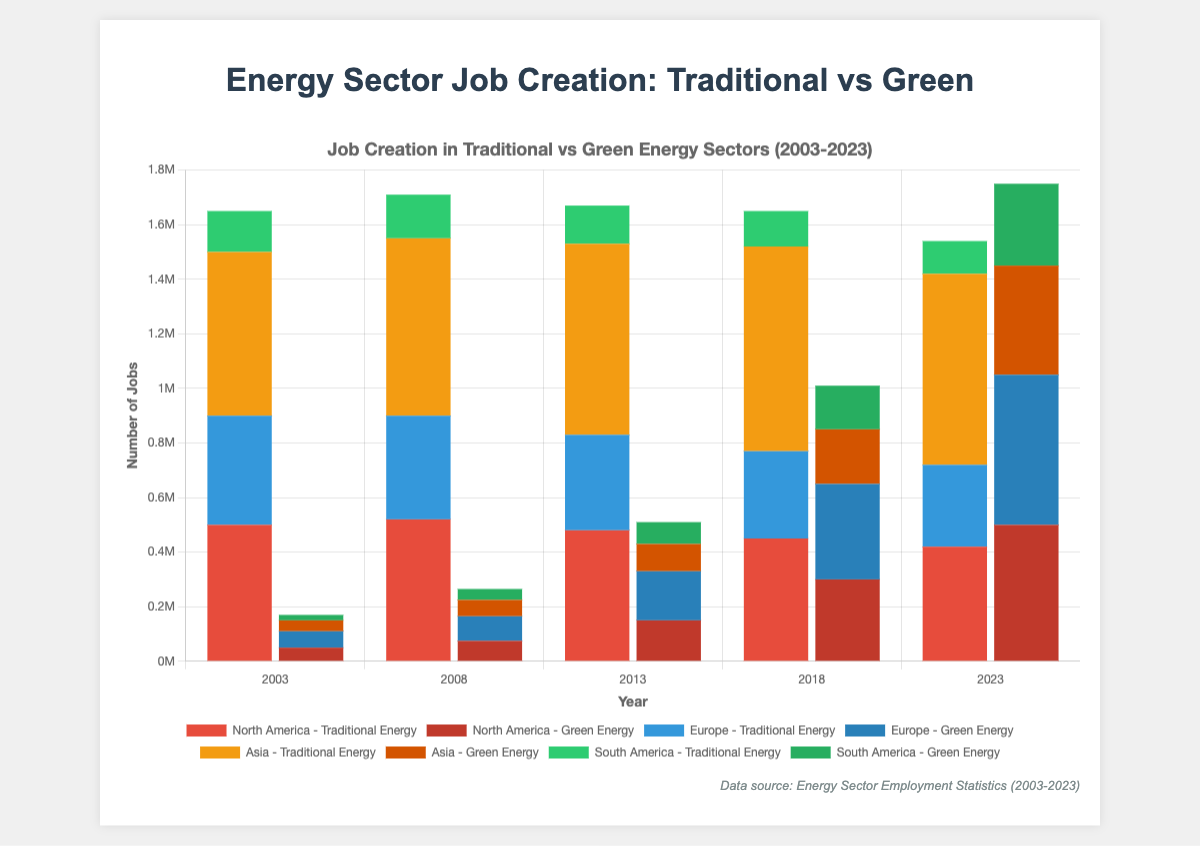Which region has the highest number of traditional energy jobs in 2023? To find the region with the highest number of traditional energy jobs in 2023, look at the height of the traditional energy jobs bars for 2023 in each region. The highest bar corresponds to Asia.
Answer: Asia How has the number of green energy jobs in Europe changed from 2003 to 2023? To determine the change, subtract the number of green energy jobs in 2003 from the number in 2023 for Europe (550,000 - 60,000).
Answer: Increased by 490,000 What’s the total number of green energy jobs across all regions in 2023? Add the green energy jobs in 2023 for North America (500,000), Europe (550,000), Asia (400,000), and South America (300,000). The total is 500,000 + 550,000 + 400,000 + 300,000.
Answer: 1,750,000 Which region shows a decline in traditional energy jobs every year? By examining the heights of the traditional energy job bars across the years for each region, Europe shows a consistent decline from 2003 to 2023.
Answer: Europe Compare the number of traditional and green energy jobs in South America in 2023? The number of traditional energy jobs in South America in 2023 is 120,000, and the number of green energy jobs is 300,000. Compare these two values to determine that green energy jobs are higher.
Answer: Green energy jobs are higher In which year did North America surpass Europe in green energy job creation? Observe the heights of the green energy job bars for North America and Europe over the years. North America surpasses Europe in 2013.
Answer: 2013 Which region has the largest increase in green energy jobs from 2003 to 2023? Calculate the difference for each region from 2003 to 2023: North America (500,000 - 50,000 = 450,000), Europe (550,000 - 60,000 = 490,000), Asia (400,000 - 40,000 = 360,000), South America (300,000 - 20,000 = 280,000). Europe has the largest increase.
Answer: Europe What is the proportion of green energy jobs in Asia compared to traditional energy jobs in 2023? Compare the green energy jobs (400,000) to traditional energy jobs (700,000) in Asia in 2023 by computing the ratio 400,000 / 700,000.
Answer: 0.57 (57%) How many more green energy jobs than traditional energy jobs were there in North America in 2023? Subtract the number of traditional energy jobs in North America in 2023 (420,000) from the number of green energy jobs (500,000).
Answer: 80,000 